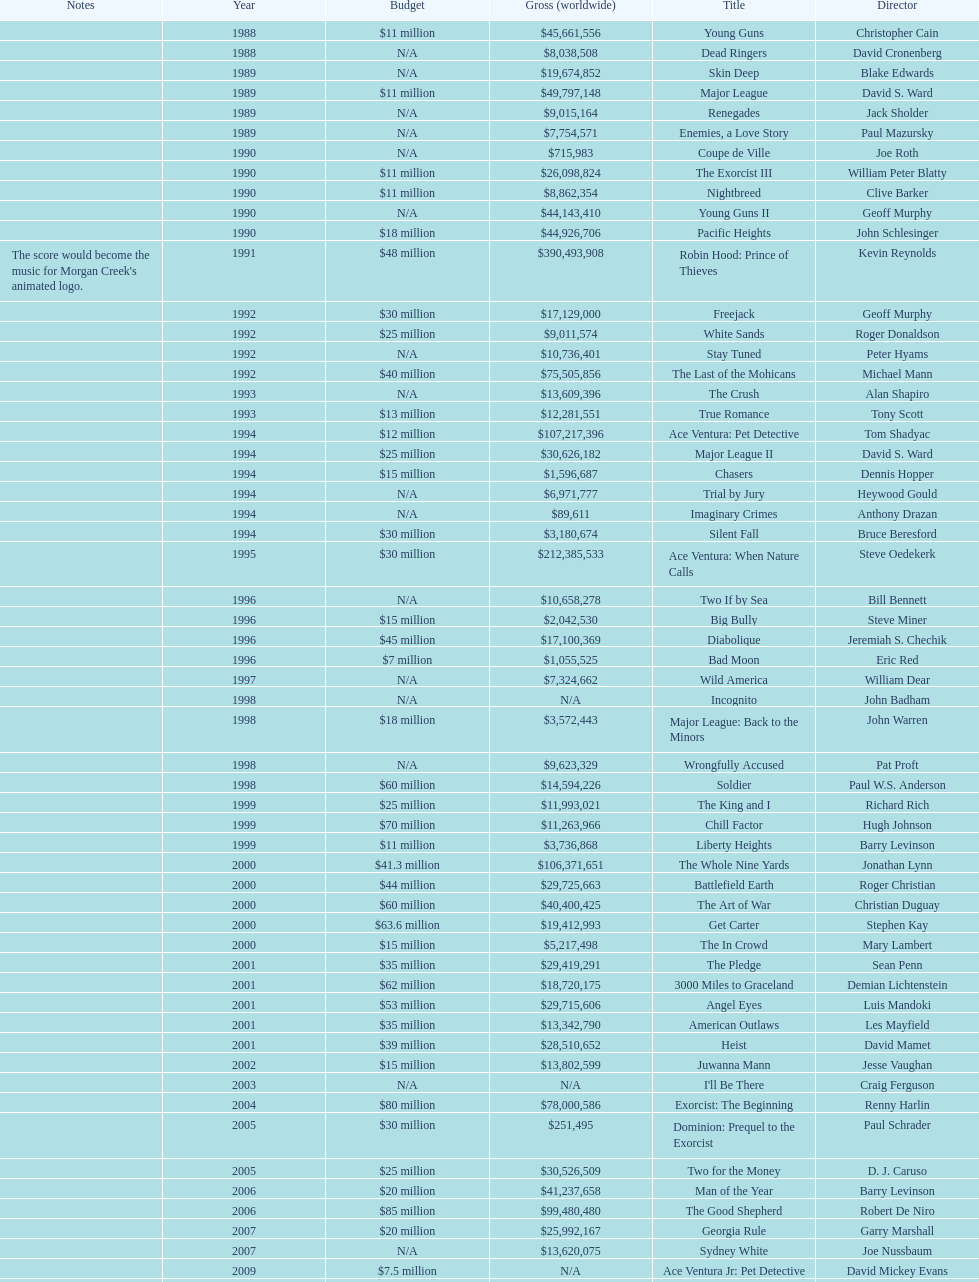What is the number of films directed by david s. ward? 2. 